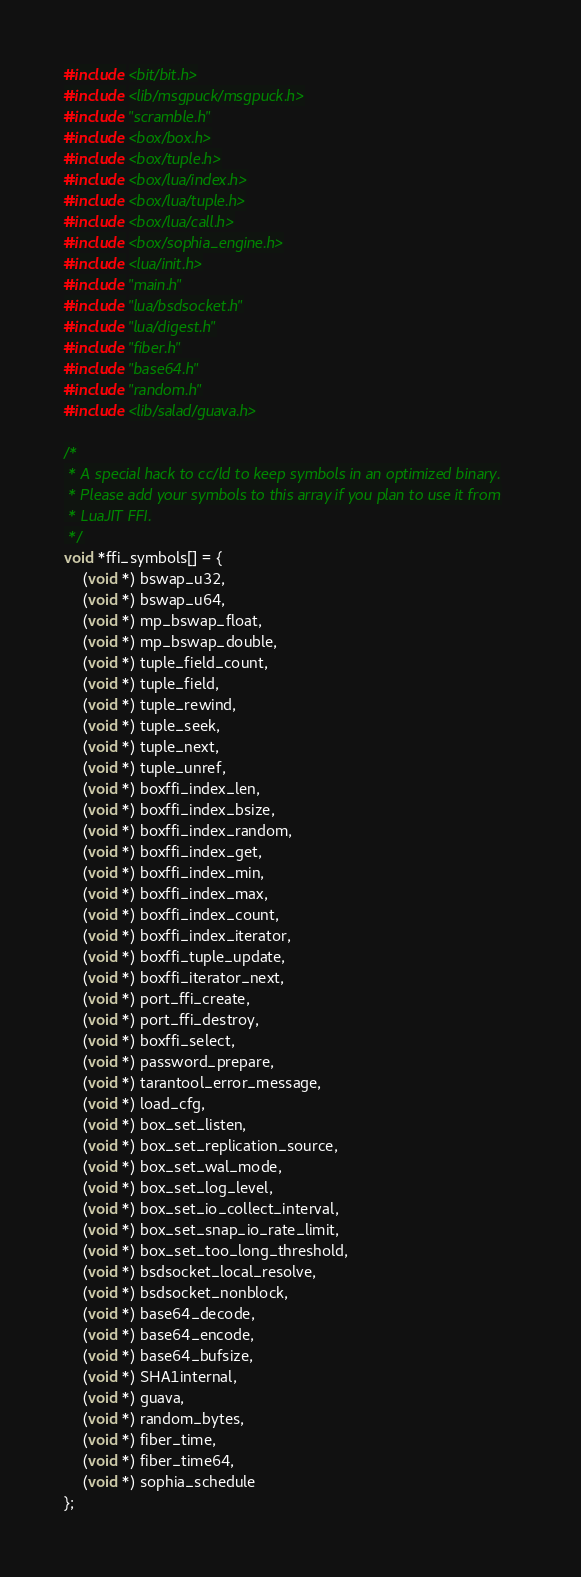Convert code to text. <code><loc_0><loc_0><loc_500><loc_500><_C++_>
#include <bit/bit.h>
#include <lib/msgpuck/msgpuck.h>
#include "scramble.h"
#include <box/box.h>
#include <box/tuple.h>
#include <box/lua/index.h>
#include <box/lua/tuple.h>
#include <box/lua/call.h>
#include <box/sophia_engine.h>
#include <lua/init.h>
#include "main.h"
#include "lua/bsdsocket.h"
#include "lua/digest.h"
#include "fiber.h"
#include "base64.h"
#include "random.h"
#include <lib/salad/guava.h>

/*
 * A special hack to cc/ld to keep symbols in an optimized binary.
 * Please add your symbols to this array if you plan to use it from
 * LuaJIT FFI.
 */
void *ffi_symbols[] = {
	(void *) bswap_u32,
	(void *) bswap_u64,
	(void *) mp_bswap_float,
	(void *) mp_bswap_double,
	(void *) tuple_field_count,
	(void *) tuple_field,
	(void *) tuple_rewind,
	(void *) tuple_seek,
	(void *) tuple_next,
	(void *) tuple_unref,
	(void *) boxffi_index_len,
	(void *) boxffi_index_bsize,
	(void *) boxffi_index_random,
	(void *) boxffi_index_get,
	(void *) boxffi_index_min,
	(void *) boxffi_index_max,
	(void *) boxffi_index_count,
	(void *) boxffi_index_iterator,
	(void *) boxffi_tuple_update,
	(void *) boxffi_iterator_next,
	(void *) port_ffi_create,
	(void *) port_ffi_destroy,
	(void *) boxffi_select,
	(void *) password_prepare,
	(void *) tarantool_error_message,
	(void *) load_cfg,
	(void *) box_set_listen,
	(void *) box_set_replication_source,
	(void *) box_set_wal_mode,
	(void *) box_set_log_level,
	(void *) box_set_io_collect_interval,
	(void *) box_set_snap_io_rate_limit,
	(void *) box_set_too_long_threshold,
	(void *) bsdsocket_local_resolve,
	(void *) bsdsocket_nonblock,
	(void *) base64_decode,
	(void *) base64_encode,
	(void *) base64_bufsize,
	(void *) SHA1internal,
	(void *) guava,
	(void *) random_bytes,
	(void *) fiber_time,
	(void *) fiber_time64,
	(void *) sophia_schedule
};
</code> 